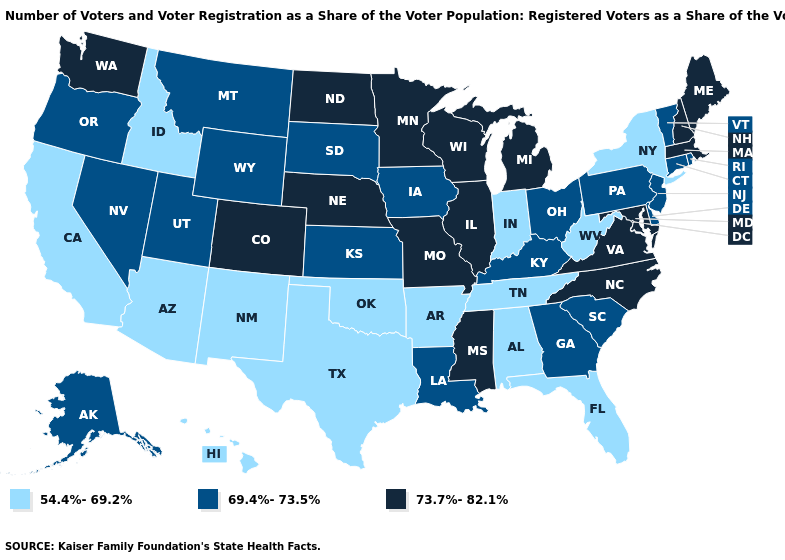Name the states that have a value in the range 54.4%-69.2%?
Keep it brief. Alabama, Arizona, Arkansas, California, Florida, Hawaii, Idaho, Indiana, New Mexico, New York, Oklahoma, Tennessee, Texas, West Virginia. What is the lowest value in the MidWest?
Short answer required. 54.4%-69.2%. Which states have the lowest value in the USA?
Concise answer only. Alabama, Arizona, Arkansas, California, Florida, Hawaii, Idaho, Indiana, New Mexico, New York, Oklahoma, Tennessee, Texas, West Virginia. What is the lowest value in the USA?
Give a very brief answer. 54.4%-69.2%. Does Alaska have the highest value in the USA?
Be succinct. No. Which states hav the highest value in the Northeast?
Give a very brief answer. Maine, Massachusetts, New Hampshire. Does Maine have the highest value in the USA?
Quick response, please. Yes. Name the states that have a value in the range 73.7%-82.1%?
Be succinct. Colorado, Illinois, Maine, Maryland, Massachusetts, Michigan, Minnesota, Mississippi, Missouri, Nebraska, New Hampshire, North Carolina, North Dakota, Virginia, Washington, Wisconsin. Does the map have missing data?
Quick response, please. No. Which states have the highest value in the USA?
Answer briefly. Colorado, Illinois, Maine, Maryland, Massachusetts, Michigan, Minnesota, Mississippi, Missouri, Nebraska, New Hampshire, North Carolina, North Dakota, Virginia, Washington, Wisconsin. What is the value of Washington?
Keep it brief. 73.7%-82.1%. Name the states that have a value in the range 73.7%-82.1%?
Short answer required. Colorado, Illinois, Maine, Maryland, Massachusetts, Michigan, Minnesota, Mississippi, Missouri, Nebraska, New Hampshire, North Carolina, North Dakota, Virginia, Washington, Wisconsin. Among the states that border North Dakota , which have the lowest value?
Keep it brief. Montana, South Dakota. What is the value of New Hampshire?
Be succinct. 73.7%-82.1%. Which states have the lowest value in the West?
Answer briefly. Arizona, California, Hawaii, Idaho, New Mexico. 